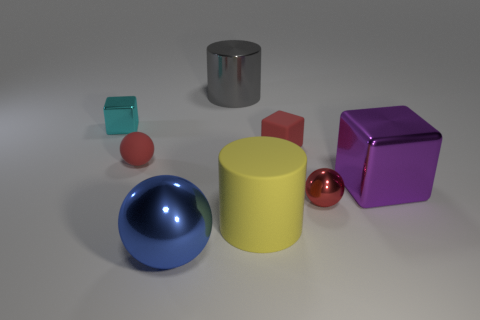Add 2 large yellow objects. How many objects exist? 10 Subtract all balls. How many objects are left? 5 Subtract all brown metallic blocks. Subtract all cylinders. How many objects are left? 6 Add 8 red shiny things. How many red shiny things are left? 9 Add 2 yellow spheres. How many yellow spheres exist? 2 Subtract 0 purple cylinders. How many objects are left? 8 